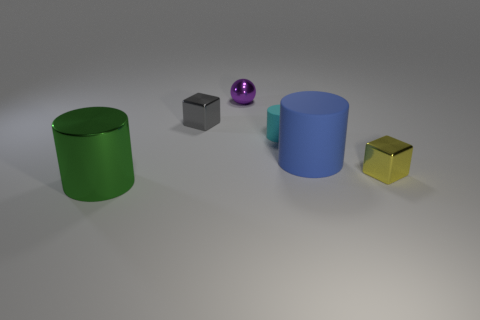Add 3 tiny cyan matte objects. How many objects exist? 9 Subtract all balls. How many objects are left? 5 Subtract all large green rubber cubes. Subtract all small gray objects. How many objects are left? 5 Add 1 tiny gray metal blocks. How many tiny gray metal blocks are left? 2 Add 3 big cyan rubber spheres. How many big cyan rubber spheres exist? 3 Subtract 0 gray cylinders. How many objects are left? 6 